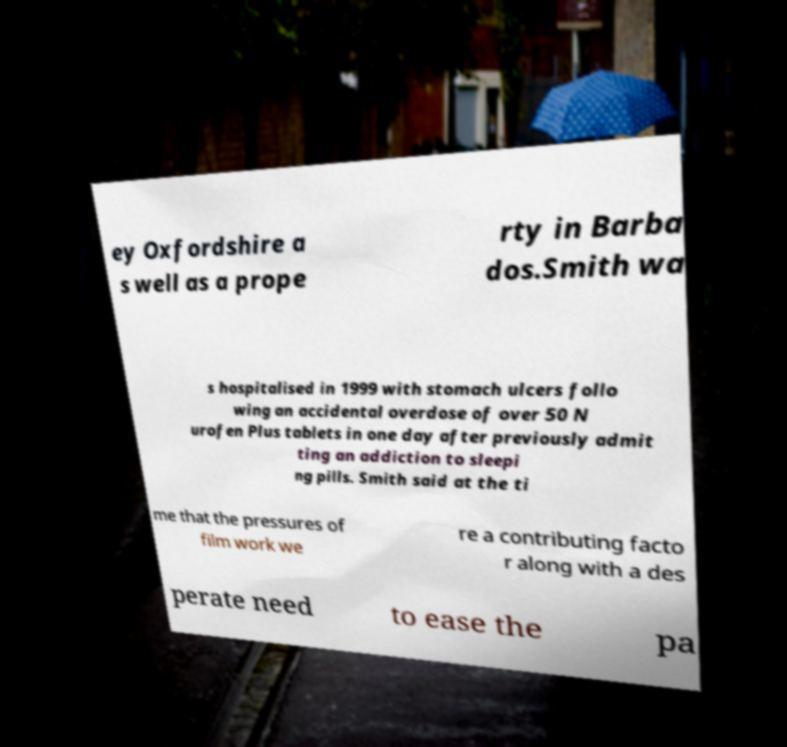Please identify and transcribe the text found in this image. ey Oxfordshire a s well as a prope rty in Barba dos.Smith wa s hospitalised in 1999 with stomach ulcers follo wing an accidental overdose of over 50 N urofen Plus tablets in one day after previously admit ting an addiction to sleepi ng pills. Smith said at the ti me that the pressures of film work we re a contributing facto r along with a des perate need to ease the pa 